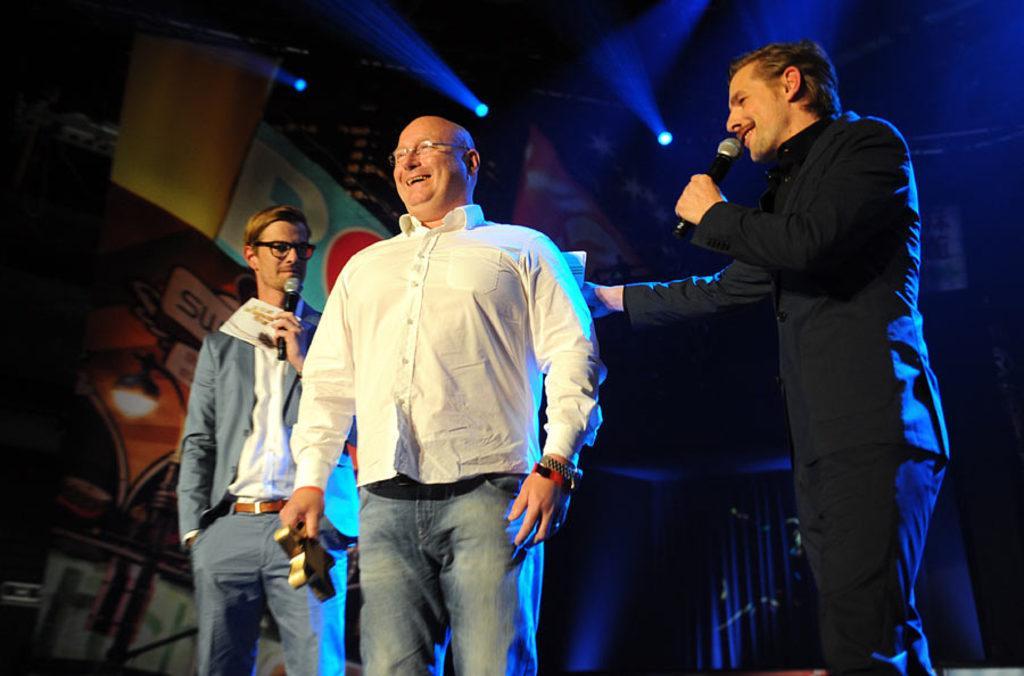Describe this image in one or two sentences. In the middle of the image few people are standing and holding some microphones and something in their hands and smiling. Behind them there is banner and lights. 